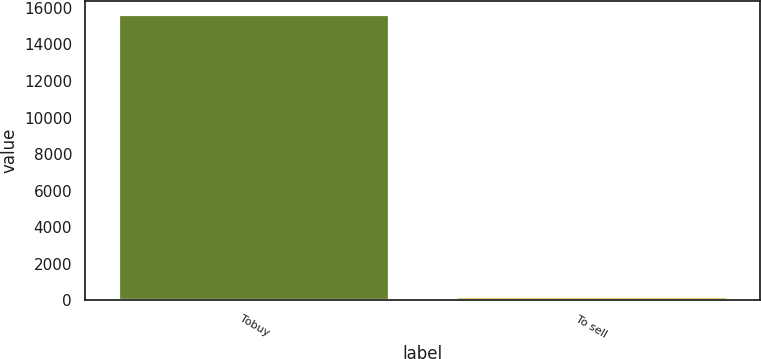<chart> <loc_0><loc_0><loc_500><loc_500><bar_chart><fcel>Tobuy<fcel>To sell<nl><fcel>15604<fcel>163<nl></chart> 